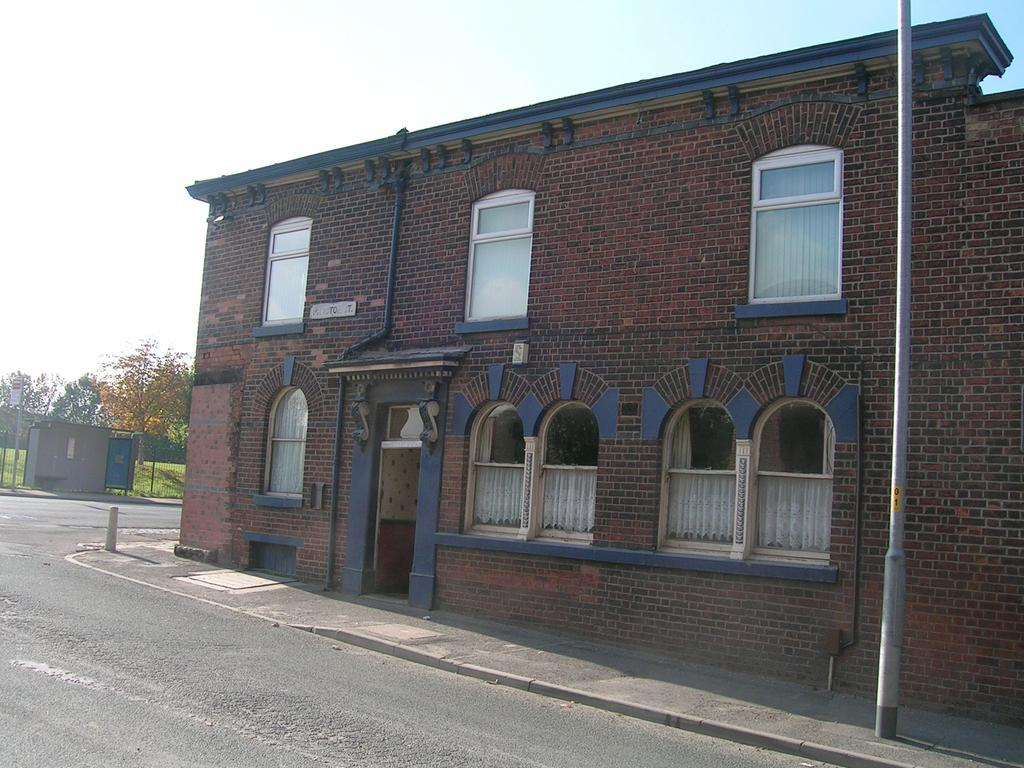What type of structure is in the image? There is a building in the image. What is located in front of the building? There is a pole and a road in front of the building. What can be seen in the sky in the image? The sky is visible at the top of the image. What is on the left side of the image? There are trees on the left side of the image. What additional feature is present in the image? A tent is visible in the image. How many snakes are slithering around the tent in the image? There are no snakes present in the image; it only features a building, pole, road, sky, trees, and a tent. What type of hospital is depicted in the image? There is no hospital depicted in the image; it only features a building, pole, road, sky, trees, and a tent. 